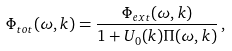Convert formula to latex. <formula><loc_0><loc_0><loc_500><loc_500>\Phi _ { t o t } ( \omega , { k } ) = \frac { \Phi _ { e x t } ( \omega , { k } ) } { 1 + U _ { 0 } ( { k } ) \Pi ( \omega , { k } ) } \, ,</formula> 